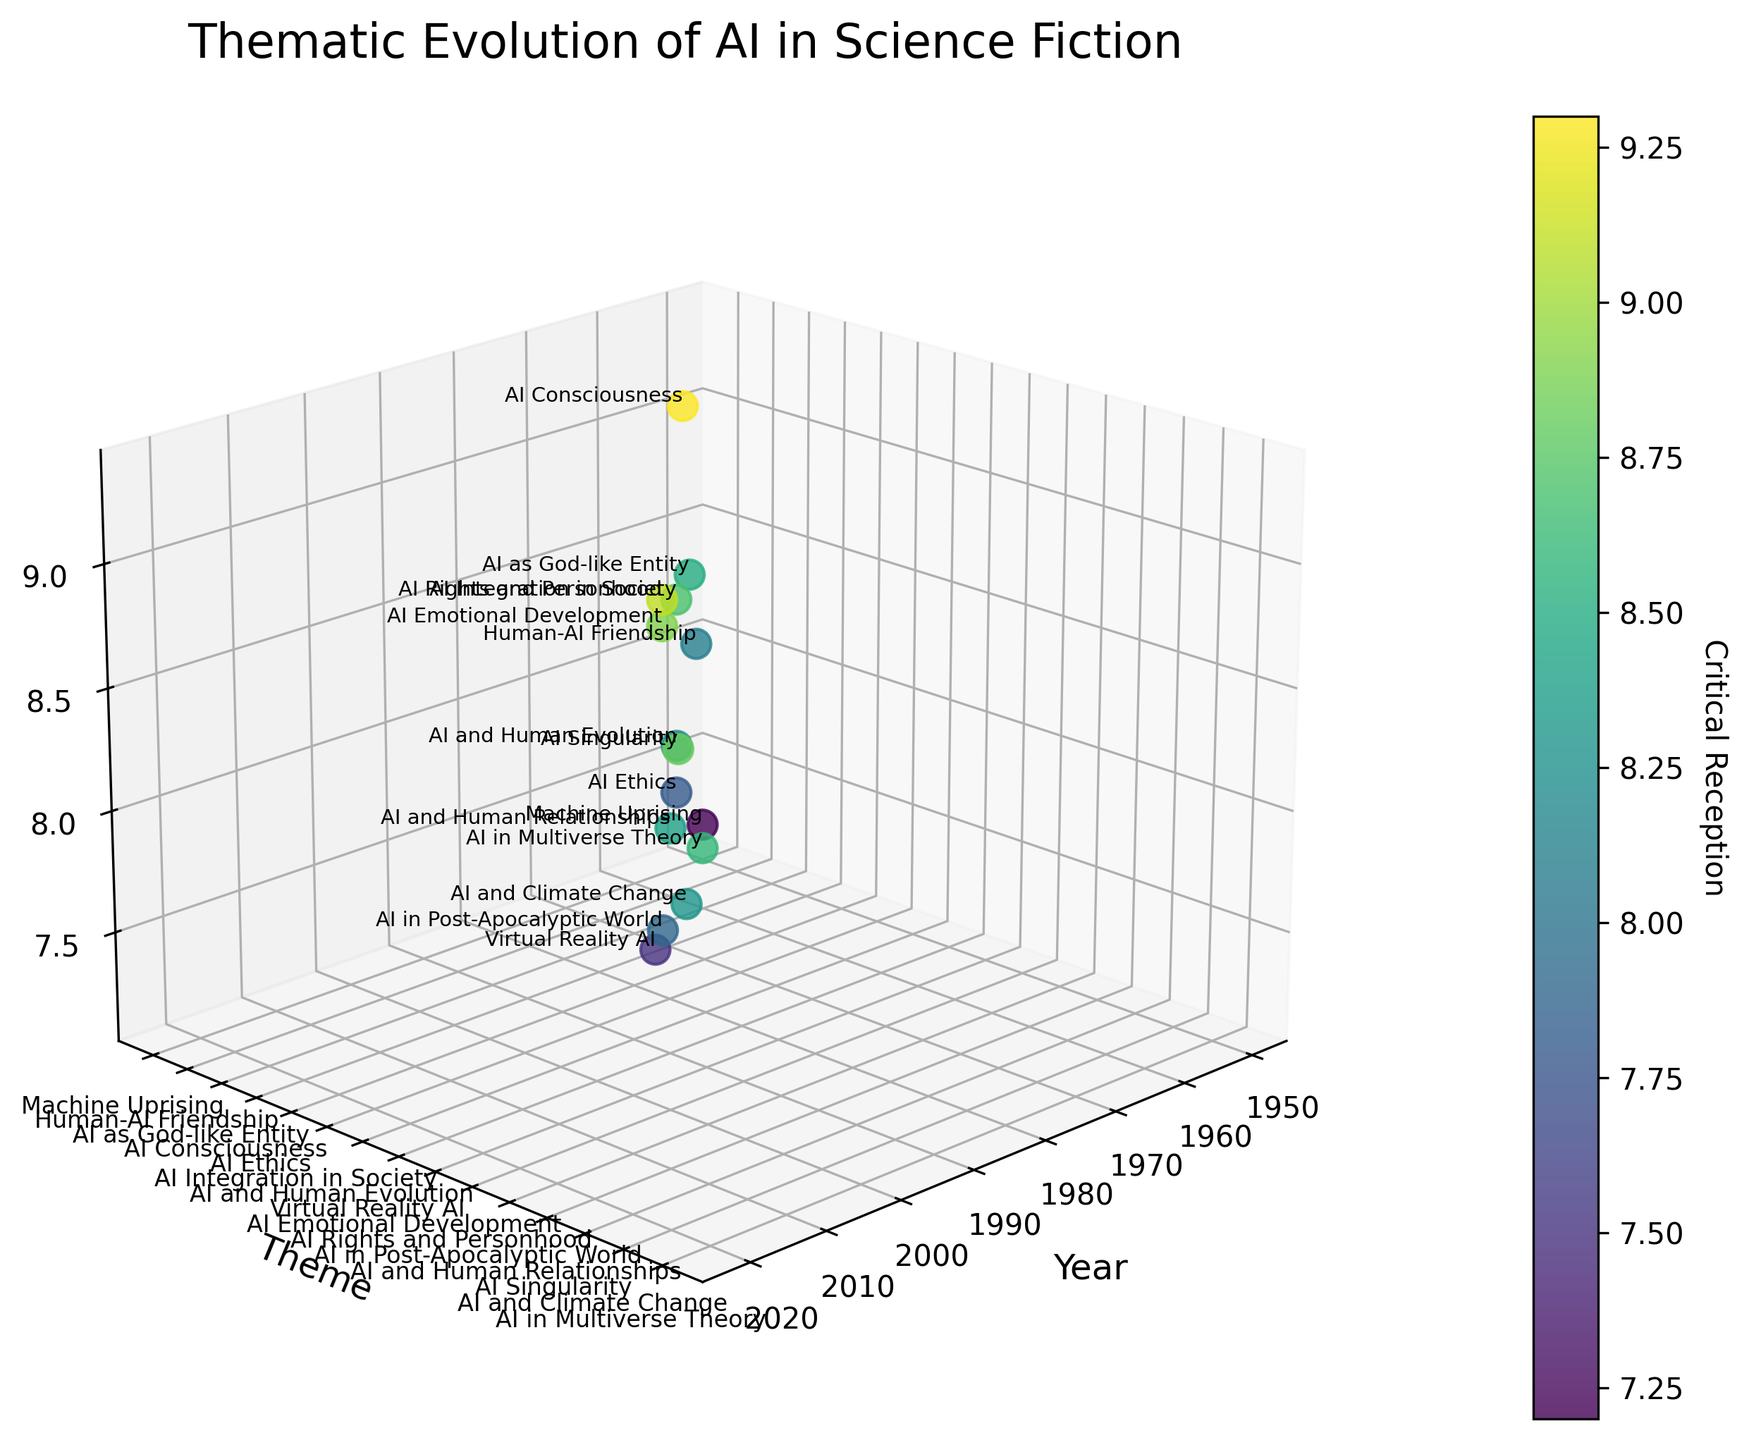what is the title of the figure? The title of the figure is displayed at the top of the plot. It summarizes the focus or main insight the plot tries to convey, which usually helps the viewer understand the visual information more quickly.
Answer: Thematic Evolution of AI in Science Fiction How is the theme "AI Singularity" received critically? Find the "AI Singularity" theme on the y-axis and refer to its corresponding dot, then look at the z-axis value to determine its critical reception.
Answer: 8.8 Which year has the highest critical reception? Refer to the z-axis values and identify the highest point. Then, check its corresponding year on the x-axis.
Answer: 1968 How many themes have a critical reception above 9.0? Look for the z-axis values that are above 9.0, and then count the corresponding themes.
Answer: 3 In which year does the theme "AI in Multiverse Theory" appear, and what's its critical reception? Locate the theme "AI in Multiverse Theory" on the y-axis, then check its corresponding year on the x-axis and its critical reception on the z-axis.
Answer: 2021, 8.6 Which themes appeared in the 1960s? Identify the data points corresponding to years in the 1960s on the x-axis, and then refer to their corresponding themes on the y-axis.
Answer: AI as God-like Entity, AI Consciousness What is the difference in critical reception between "Human-AI Friendship" and "Machine Uprising"? Find the critical receptions corresponding to "Human-AI Friendship" and "Machine Uprising" from the z-axis, then subtract the smaller value from the larger one.
Answer: 0.9 Which theme relates to AI rights and is among the highest critically acclaimed? Identify the theme on the y-axis that mentions AI rights and check its z-axis value to affirm that it is among the highest-rated critical receptions.
Answer: AI Rights and Personhood Which decade sees the most diversified themes? Count the different themes for each decade by summing up the data points from corresponding years and identify the decade with the most themes.
Answer: 2000s Are any themes decreasing in critical reception through time? Compare the critical reception values on the z-axis for sequential years to identify if any theme appears to have a consistently decreasing reception over different time points.
Answer: No 